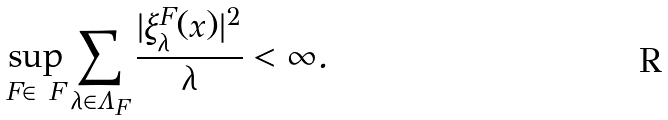Convert formula to latex. <formula><loc_0><loc_0><loc_500><loc_500>\sup _ { F \in \ F } \sum _ { \lambda \in \Lambda _ { F } } \frac { | \xi _ { \lambda } ^ { F } ( x ) | ^ { 2 } } { \lambda } < \infty .</formula> 